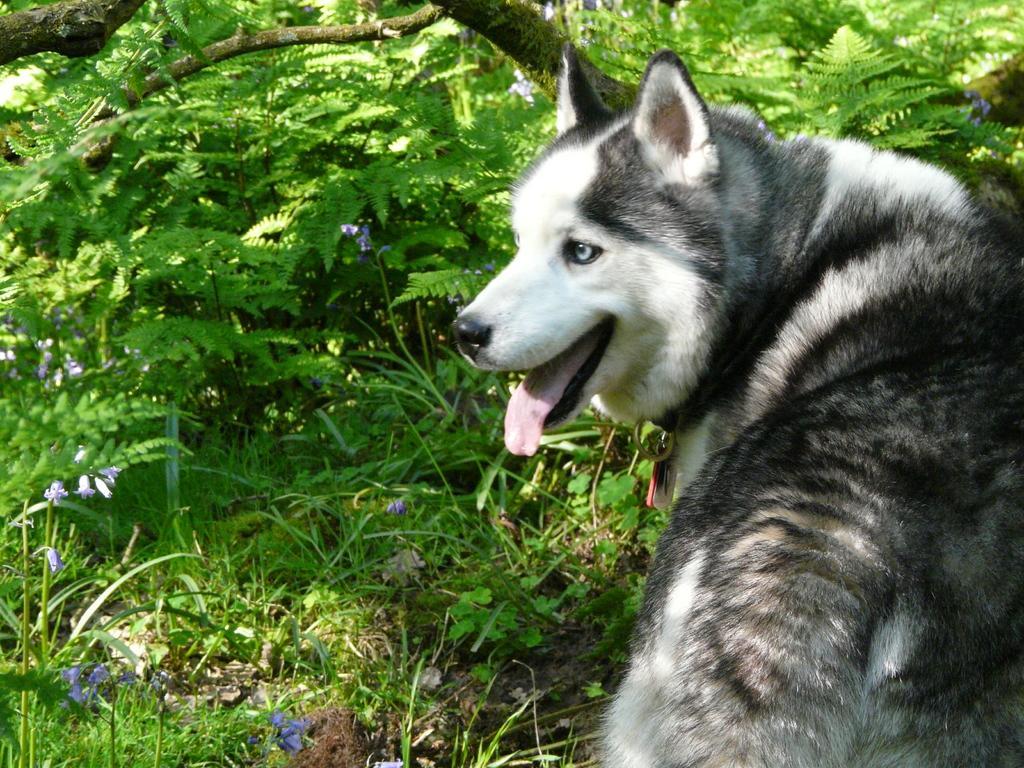Please provide a concise description of this image. In this picture we can see a husky dog and behind the dog there is a branch, grass and plants with flowers. 